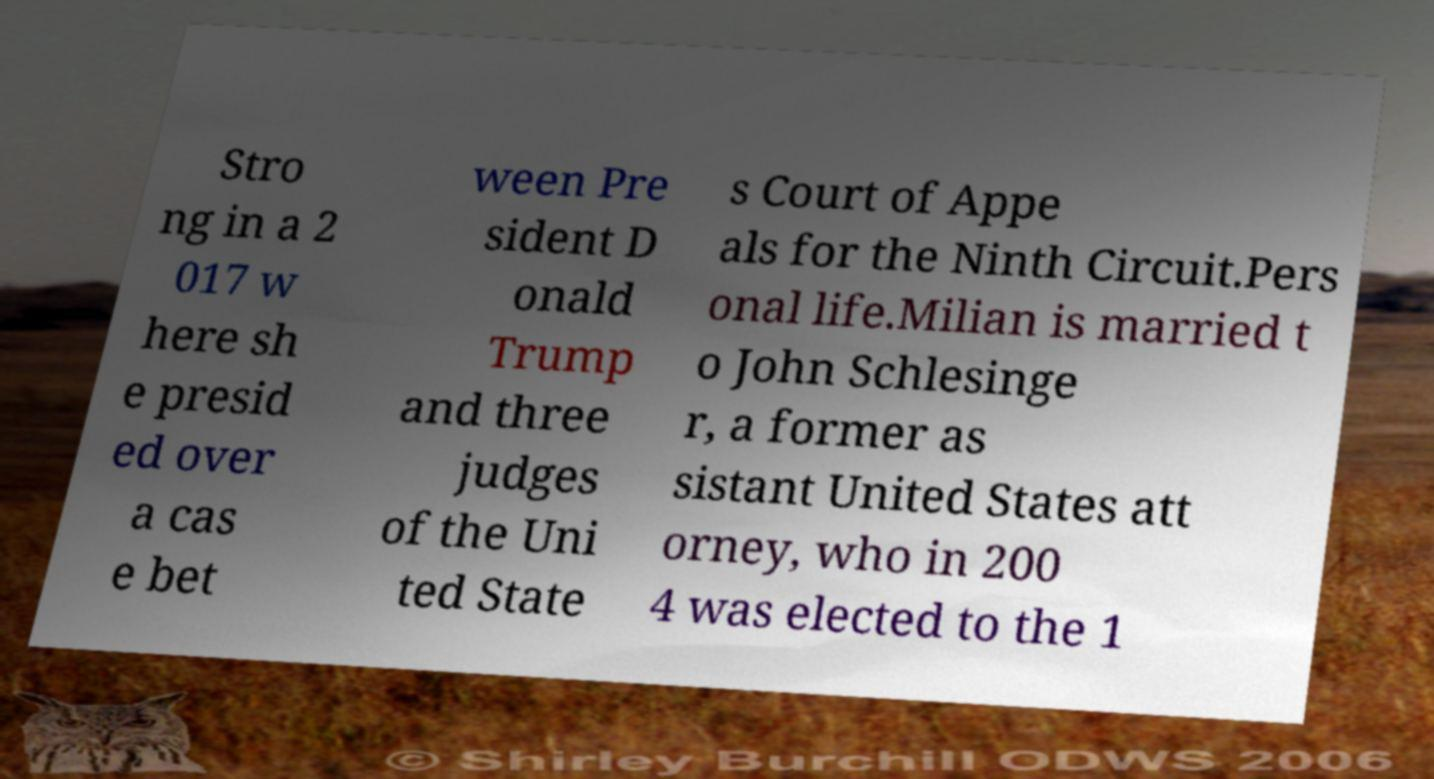There's text embedded in this image that I need extracted. Can you transcribe it verbatim? Stro ng in a 2 017 w here sh e presid ed over a cas e bet ween Pre sident D onald Trump and three judges of the Uni ted State s Court of Appe als for the Ninth Circuit.Pers onal life.Milian is married t o John Schlesinge r, a former as sistant United States att orney, who in 200 4 was elected to the 1 